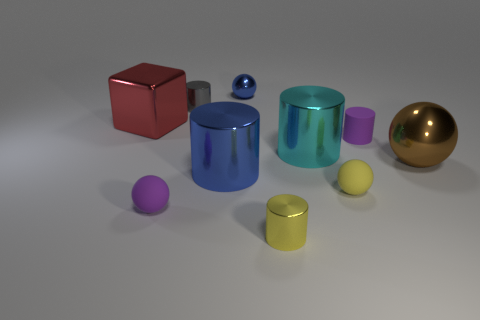What is the shape of the shiny thing that is both behind the large red metallic thing and right of the tiny gray metal thing?
Make the answer very short. Sphere. Is there a tiny matte thing of the same shape as the brown metal thing?
Offer a very short reply. Yes. The blue metallic thing that is the same size as the yellow metal cylinder is what shape?
Your answer should be very brief. Sphere. What material is the blue cylinder?
Your answer should be compact. Metal. How big is the red metallic object that is to the left of the metallic ball to the left of the small purple rubber thing behind the brown sphere?
Keep it short and to the point. Large. There is a thing that is the same color as the matte cylinder; what is its material?
Make the answer very short. Rubber. What number of metallic objects are yellow spheres or tiny cubes?
Provide a short and direct response. 0. How big is the purple ball?
Your answer should be very brief. Small. What number of objects are either small balls or tiny metal objects that are in front of the big red metal cube?
Offer a terse response. 4. What number of other objects are the same color as the tiny metal ball?
Provide a succinct answer. 1. 